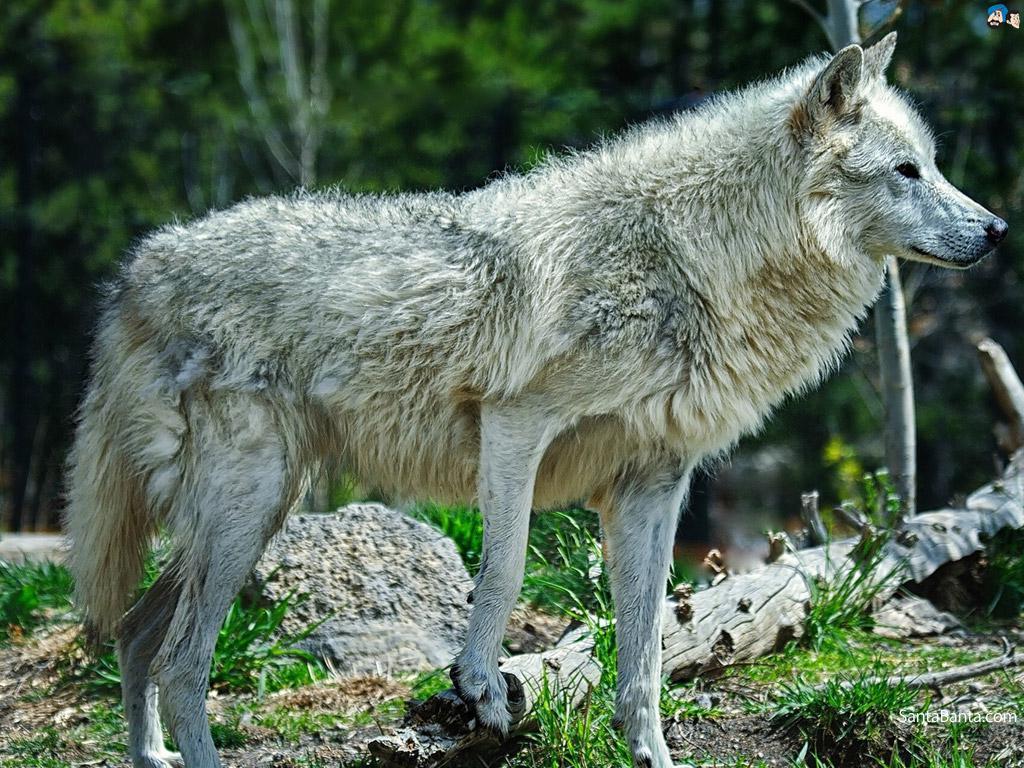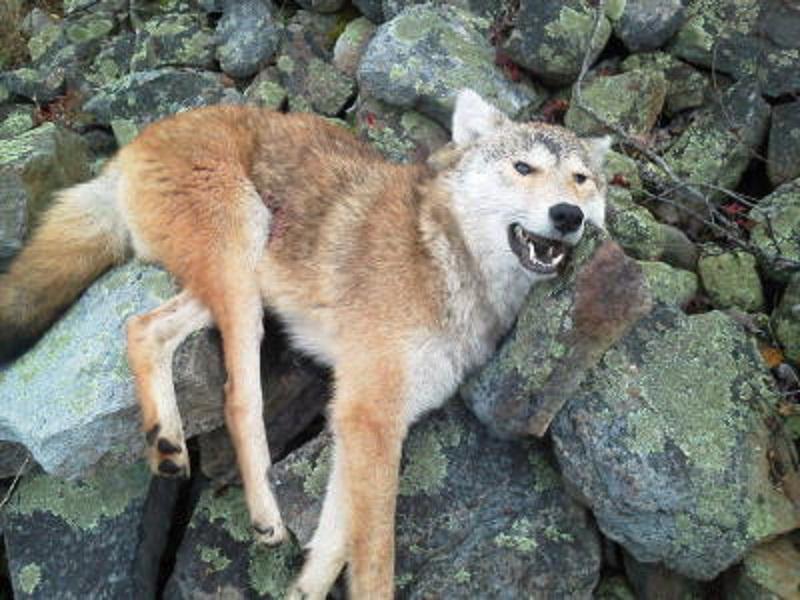The first image is the image on the left, the second image is the image on the right. Considering the images on both sides, is "Each image contains exactly one wolf, and one image shows a wolf with an open, non-snarling mouth." valid? Answer yes or no. Yes. The first image is the image on the left, the second image is the image on the right. Analyze the images presented: Is the assertion "At least one wolf is grey and one is tan." valid? Answer yes or no. Yes. 